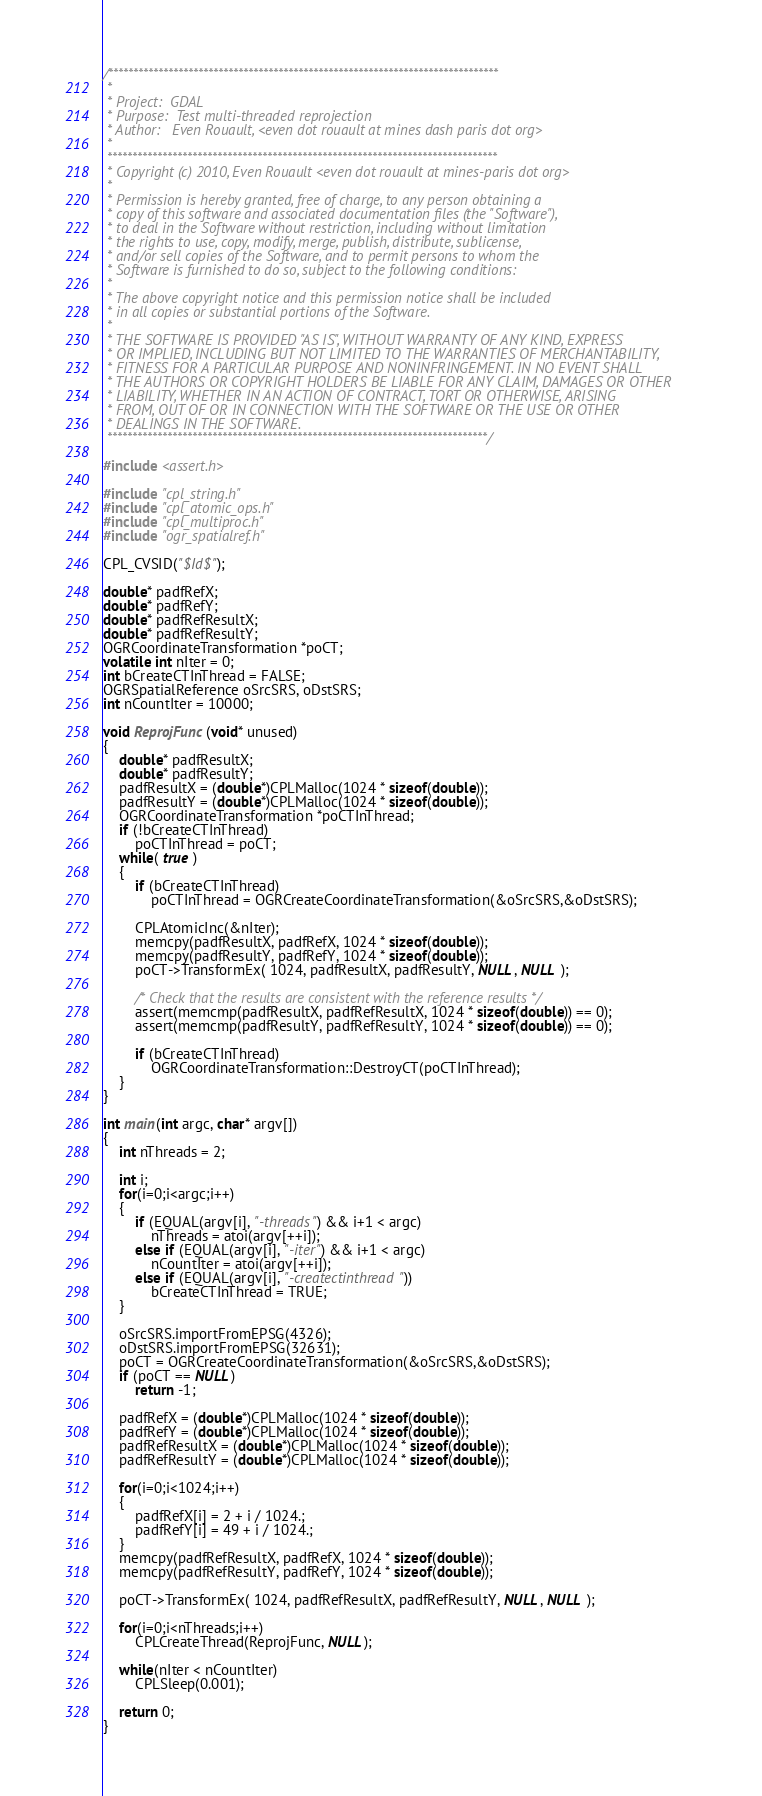<code> <loc_0><loc_0><loc_500><loc_500><_C++_>/******************************************************************************
 *
 * Project:  GDAL
 * Purpose:  Test multi-threaded reprojection
 * Author:   Even Rouault, <even dot rouault at mines dash paris dot org>
 *
 ******************************************************************************
 * Copyright (c) 2010, Even Rouault <even dot rouault at mines-paris dot org>
 *
 * Permission is hereby granted, free of charge, to any person obtaining a
 * copy of this software and associated documentation files (the "Software"),
 * to deal in the Software without restriction, including without limitation
 * the rights to use, copy, modify, merge, publish, distribute, sublicense,
 * and/or sell copies of the Software, and to permit persons to whom the
 * Software is furnished to do so, subject to the following conditions:
 *
 * The above copyright notice and this permission notice shall be included
 * in all copies or substantial portions of the Software.
 *
 * THE SOFTWARE IS PROVIDED "AS IS", WITHOUT WARRANTY OF ANY KIND, EXPRESS
 * OR IMPLIED, INCLUDING BUT NOT LIMITED TO THE WARRANTIES OF MERCHANTABILITY,
 * FITNESS FOR A PARTICULAR PURPOSE AND NONINFRINGEMENT. IN NO EVENT SHALL
 * THE AUTHORS OR COPYRIGHT HOLDERS BE LIABLE FOR ANY CLAIM, DAMAGES OR OTHER
 * LIABILITY, WHETHER IN AN ACTION OF CONTRACT, TORT OR OTHERWISE, ARISING
 * FROM, OUT OF OR IN CONNECTION WITH THE SOFTWARE OR THE USE OR OTHER
 * DEALINGS IN THE SOFTWARE.
 ****************************************************************************/

#include <assert.h>

#include "cpl_string.h"
#include "cpl_atomic_ops.h"
#include "cpl_multiproc.h"
#include "ogr_spatialref.h"

CPL_CVSID("$Id$");

double* padfRefX;
double* padfRefY;
double* padfRefResultX;
double* padfRefResultY;
OGRCoordinateTransformation *poCT;
volatile int nIter = 0;
int bCreateCTInThread = FALSE;
OGRSpatialReference oSrcSRS, oDstSRS;
int nCountIter = 10000;

void ReprojFunc(void* unused)
{
    double* padfResultX;
    double* padfResultY;
    padfResultX = (double*)CPLMalloc(1024 * sizeof(double));
    padfResultY = (double*)CPLMalloc(1024 * sizeof(double));
    OGRCoordinateTransformation *poCTInThread;
    if (!bCreateCTInThread)
        poCTInThread = poCT;
    while( true )
    {
        if (bCreateCTInThread)
            poCTInThread = OGRCreateCoordinateTransformation(&oSrcSRS,&oDstSRS);

        CPLAtomicInc(&nIter);
        memcpy(padfResultX, padfRefX, 1024 * sizeof(double));
        memcpy(padfResultY, padfRefY, 1024 * sizeof(double));
        poCT->TransformEx( 1024, padfResultX, padfResultY, NULL, NULL );

        /* Check that the results are consistent with the reference results */
        assert(memcmp(padfResultX, padfRefResultX, 1024 * sizeof(double)) == 0);
        assert(memcmp(padfResultY, padfRefResultY, 1024 * sizeof(double)) == 0);

        if (bCreateCTInThread)
            OGRCoordinateTransformation::DestroyCT(poCTInThread);
    }
}

int main(int argc, char* argv[])
{
    int nThreads = 2;

    int i;
    for(i=0;i<argc;i++)
    {
        if (EQUAL(argv[i], "-threads") && i+1 < argc)
            nThreads = atoi(argv[++i]);
        else if (EQUAL(argv[i], "-iter") && i+1 < argc)
            nCountIter = atoi(argv[++i]);
        else if (EQUAL(argv[i], "-createctinthread"))
            bCreateCTInThread = TRUE;
    }

    oSrcSRS.importFromEPSG(4326);
    oDstSRS.importFromEPSG(32631);
    poCT = OGRCreateCoordinateTransformation(&oSrcSRS,&oDstSRS);
    if (poCT == NULL)
        return -1;

    padfRefX = (double*)CPLMalloc(1024 * sizeof(double));
    padfRefY = (double*)CPLMalloc(1024 * sizeof(double));
    padfRefResultX = (double*)CPLMalloc(1024 * sizeof(double));
    padfRefResultY = (double*)CPLMalloc(1024 * sizeof(double));

    for(i=0;i<1024;i++)
    {
        padfRefX[i] = 2 + i / 1024.;
        padfRefY[i] = 49 + i / 1024.;
    }
    memcpy(padfRefResultX, padfRefX, 1024 * sizeof(double));
    memcpy(padfRefResultY, padfRefY, 1024 * sizeof(double));

    poCT->TransformEx( 1024, padfRefResultX, padfRefResultY, NULL, NULL );

    for(i=0;i<nThreads;i++)
        CPLCreateThread(ReprojFunc, NULL);

    while(nIter < nCountIter)
        CPLSleep(0.001);

    return 0;
}
</code> 